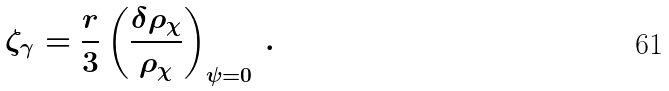Convert formula to latex. <formula><loc_0><loc_0><loc_500><loc_500>\zeta _ { \gamma } = \frac { r } { 3 } \left ( \frac { \delta \rho _ { \chi } } { \rho _ { \chi } } \right ) _ { \psi = 0 } \, .</formula> 